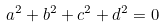<formula> <loc_0><loc_0><loc_500><loc_500>a ^ { 2 } + b ^ { 2 } + c ^ { 2 } + d ^ { 2 } = 0</formula> 